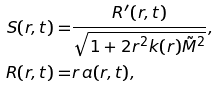<formula> <loc_0><loc_0><loc_500><loc_500>S ( r , t ) = & \frac { R ^ { \prime } ( r , t ) } { \sqrt { 1 + 2 r ^ { 2 } k ( r ) \tilde { M } ^ { 2 } } } , \\ R ( r , t ) = & r \, a ( r , t ) ,</formula> 